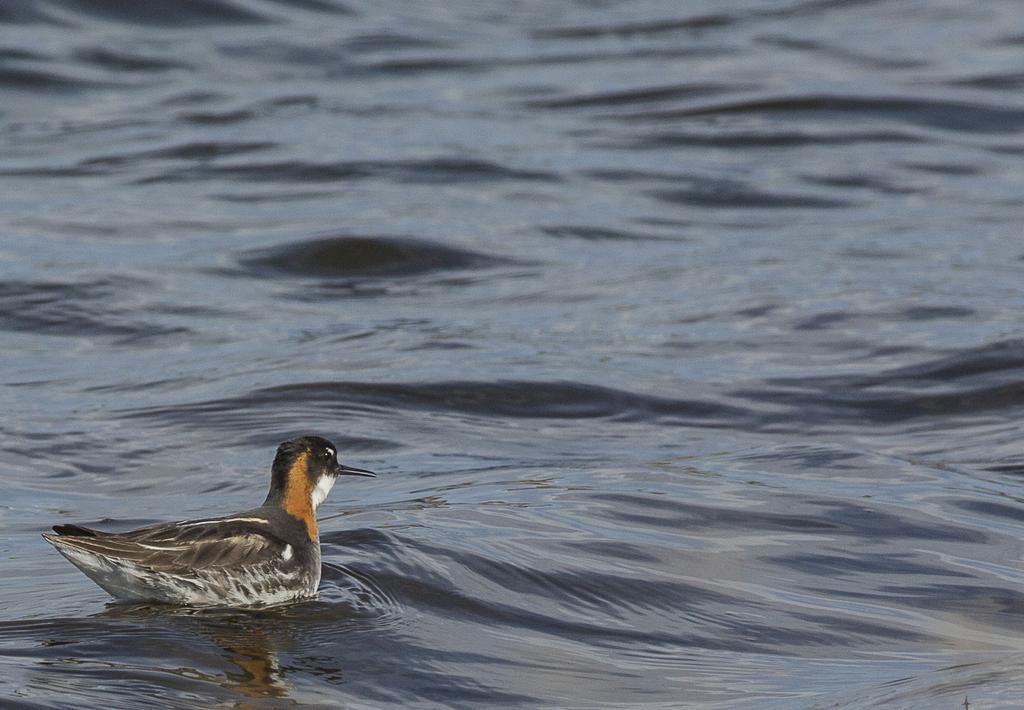Please provide a concise description of this image. In this image I can see a duck in the water. 